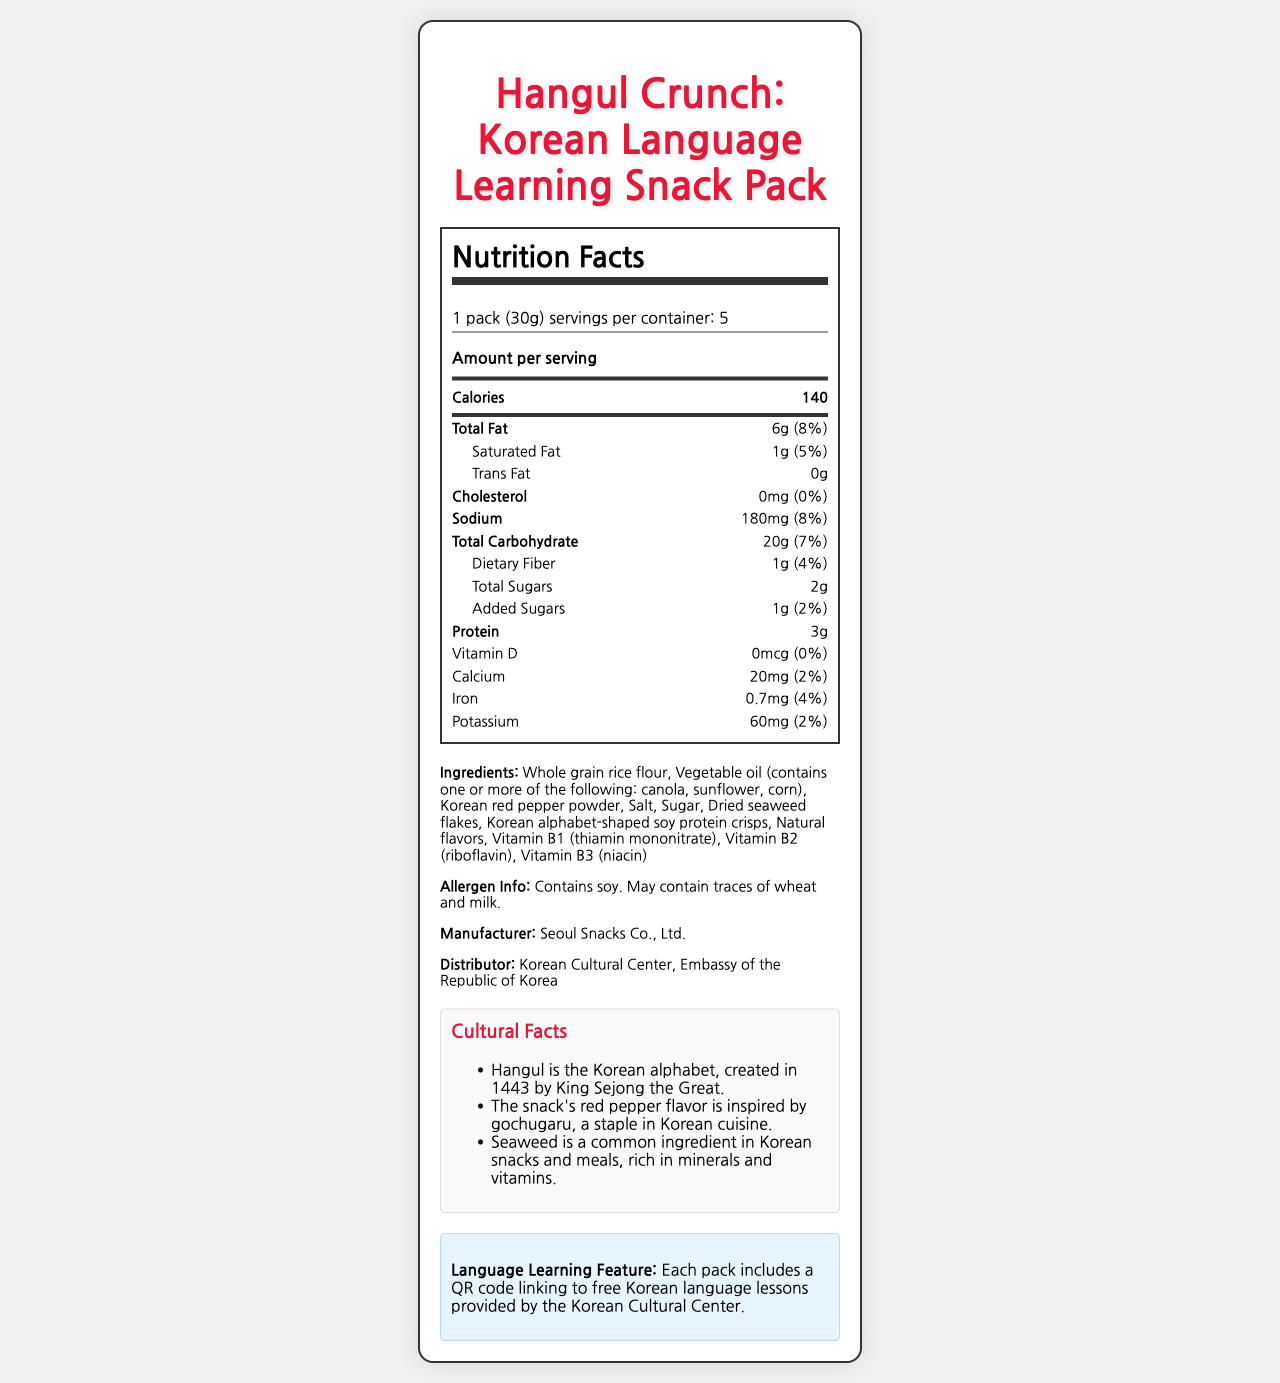What is the serving size of Hangul Crunch? The serving size is stated as "1 pack (30g)" in the serving information section.
Answer: 1 pack (30g) How many calories are in one serving of Hangul Crunch? The document lists 140 calories under the main nutrients section, specifically labelled "Calories."
Answer: 140 What is the daily value percentage of Total Fat in Hangul Crunch? The total fat section specifies that the amount is "6g" and the daily value is "8%."
Answer: 8% How much dietary fiber does one serving of Hangul Crunch contain? The nutritional information lists dietary fiber as "1g."
Answer: 1g List three main ingredients in Hangul Crunch. The ingredients section lists these three ingredients among others.
Answer: Whole grain rice flour, Vegetable oil, Korean red pepper powder Which of the following is an allergen contained in Hangul Crunch? 
A. Nuts
B. Soy
C. Eggs
D. Peanuts The allergen information section specifies that the product contains soy.
Answer: B What cultural fact is mentioned about seaweed in the document? 
A. It is rich in proteins.
B. It is used in Korean desserts.
C. It is rich in minerals and vitamins.
D. It was created by King Sejong. The cultural facts section mentions, "Seaweed is a common ingredient in Korean snacks and meals, rich in minerals and vitamins."
Answer: C Is the product cholesterol-free? The nutritional information lists the cholesterol content as "0mg" and the daily value as "0%."
Answer: Yes Summarize the main idea of the document. The document provides a comprehensive overview of Hangul Crunch, including nutritional information, ingredients, allergen details, and its educational and cultural significance.
Answer: Hangul Crunch is a Korean language-learning snack pack with crispy rice crackers shaped like Hangul characters. It provides nutritional details and highlights cultural facts. The product promotes cultural exchange by including QR codes linked to free Korean language lessons. What is the daily value percentage of added sugars in Hangul Crunch? The added sugars section indicates "1g" and "2%" for the daily value.
Answer: 2% Who is the manufacturer of Hangul Crunch? The manufacturer section states, "Seoul Snacks Co., Ltd."
Answer: Seoul Snacks Co., Ltd. What is the source of the QR code included in the Hangul Crunch pack? The language learning feature mentions the QR code links to lessons provided by the Korean Cultural Center.
Answer: Korean Cultural Center How many servings are there in one container of Hangul Crunch? The serving information indicates that there are 5 servings per container.
Answer: 5 Does the document specify the price of Hangul Crunch? The document does not contain any details regarding the pricing of Hangul Crunch.
Answer: Not enough information 